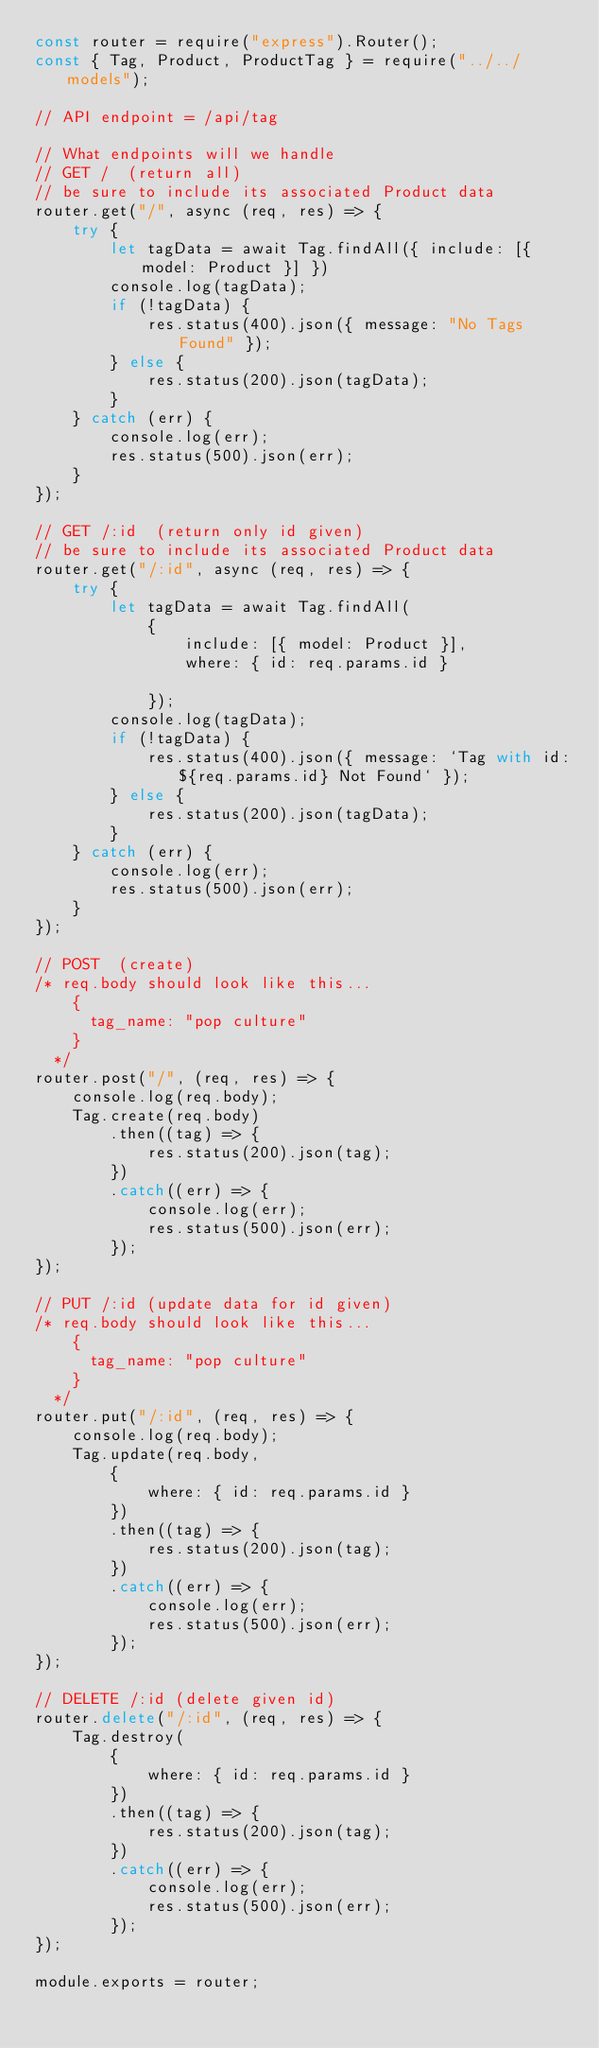<code> <loc_0><loc_0><loc_500><loc_500><_JavaScript_>const router = require("express").Router();
const { Tag, Product, ProductTag } = require("../../models");

// API endpoint = /api/tag

// What endpoints will we handle
// GET /  (return all)
// be sure to include its associated Product data
router.get("/", async (req, res) => {
    try {
        let tagData = await Tag.findAll({ include: [{ model: Product }] })
        console.log(tagData);
        if (!tagData) {
            res.status(400).json({ message: "No Tags Found" });
        } else {
            res.status(200).json(tagData);
        }
    } catch (err) {
        console.log(err);
        res.status(500).json(err);
    }
});

// GET /:id  (return only id given)
// be sure to include its associated Product data
router.get("/:id", async (req, res) => {
    try {
        let tagData = await Tag.findAll(
            {
                include: [{ model: Product }],
                where: { id: req.params.id }
                
            });
        console.log(tagData);
        if (!tagData) {
            res.status(400).json({ message: `Tag with id:${req.params.id} Not Found` });
        } else {
            res.status(200).json(tagData);
        }
    } catch (err) {
        console.log(err);
        res.status(500).json(err);
    }
});

// POST  (create)
/* req.body should look like this...
    {
      tag_name: "pop culture"
    }
  */
router.post("/", (req, res) => {
    console.log(req.body);
    Tag.create(req.body)
        .then((tag) => {
            res.status(200).json(tag);
        })
        .catch((err) => {
            console.log(err);
            res.status(500).json(err);
        });
});

// PUT /:id (update data for id given)
/* req.body should look like this...
    {
      tag_name: "pop culture"
    }
  */
router.put("/:id", (req, res) => {
    console.log(req.body);
    Tag.update(req.body,
        {
            where: { id: req.params.id }
        })
        .then((tag) => {
            res.status(200).json(tag);
        })
        .catch((err) => {
            console.log(err);
            res.status(500).json(err);
        });
});

// DELETE /:id (delete given id)
router.delete("/:id", (req, res) => {
    Tag.destroy(
        {
            where: { id: req.params.id }
        })
        .then((tag) => {
            res.status(200).json(tag);
        })
        .catch((err) => {
            console.log(err);
            res.status(500).json(err);
        });
});

module.exports = router;</code> 